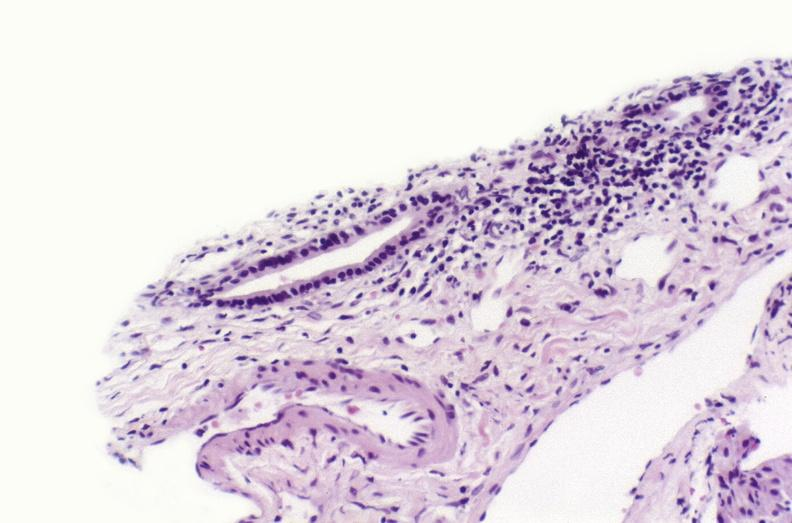s fracture present?
Answer the question using a single word or phrase. No 